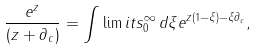<formula> <loc_0><loc_0><loc_500><loc_500>\frac { e ^ { z } } { ( z + \partial _ { c } ) } = \int \lim i t s ^ { \infty } _ { 0 } \, d \xi e ^ { z ( 1 - \xi ) - \xi \partial _ { c } } ,</formula> 